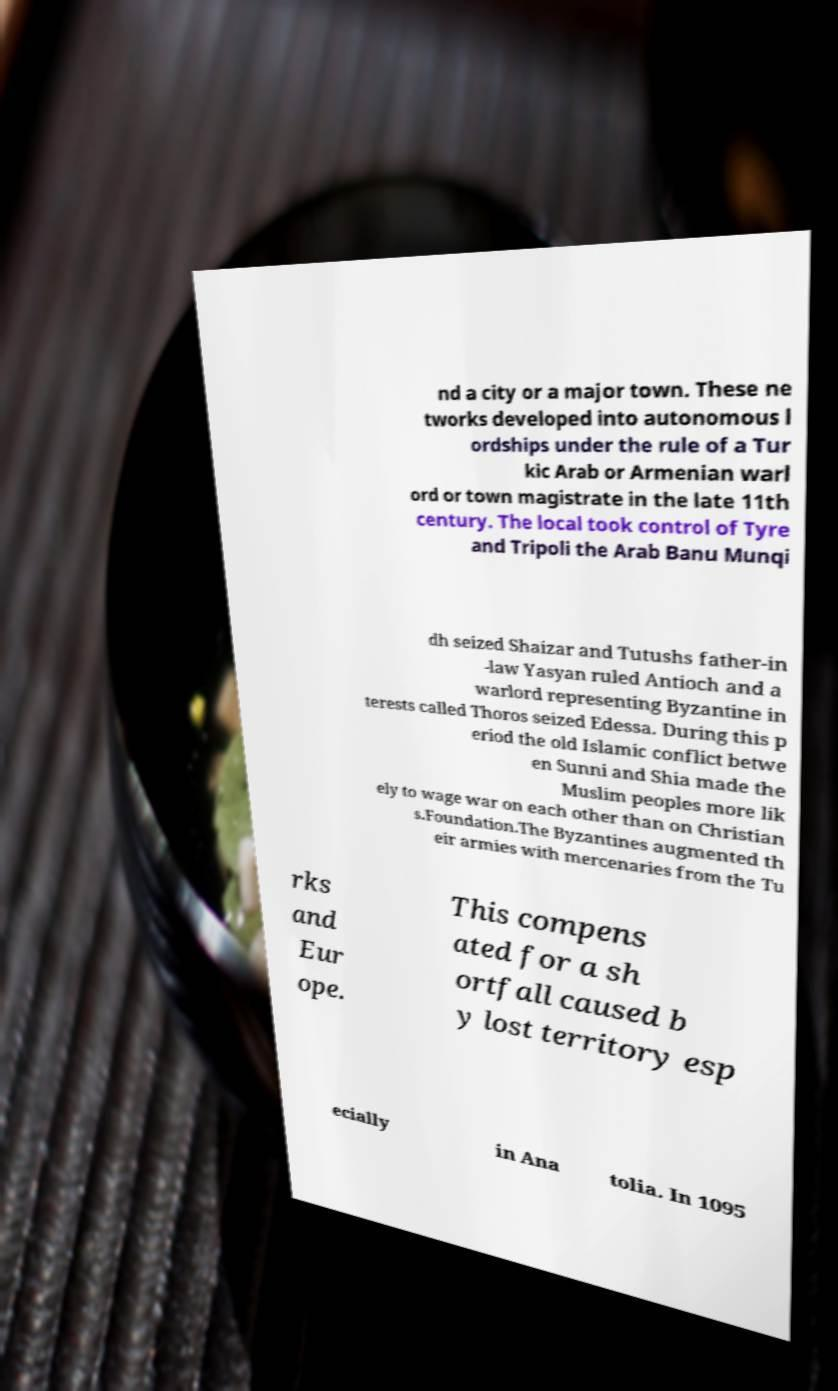Can you accurately transcribe the text from the provided image for me? nd a city or a major town. These ne tworks developed into autonomous l ordships under the rule of a Tur kic Arab or Armenian warl ord or town magistrate in the late 11th century. The local took control of Tyre and Tripoli the Arab Banu Munqi dh seized Shaizar and Tutushs father-in -law Yasyan ruled Antioch and a warlord representing Byzantine in terests called Thoros seized Edessa. During this p eriod the old Islamic conflict betwe en Sunni and Shia made the Muslim peoples more lik ely to wage war on each other than on Christian s.Foundation.The Byzantines augmented th eir armies with mercenaries from the Tu rks and Eur ope. This compens ated for a sh ortfall caused b y lost territory esp ecially in Ana tolia. In 1095 